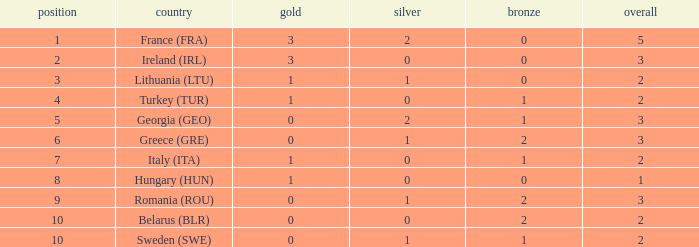What's the total number of bronze medals for Sweden (SWE) having less than 1 gold and silver? 0.0. 